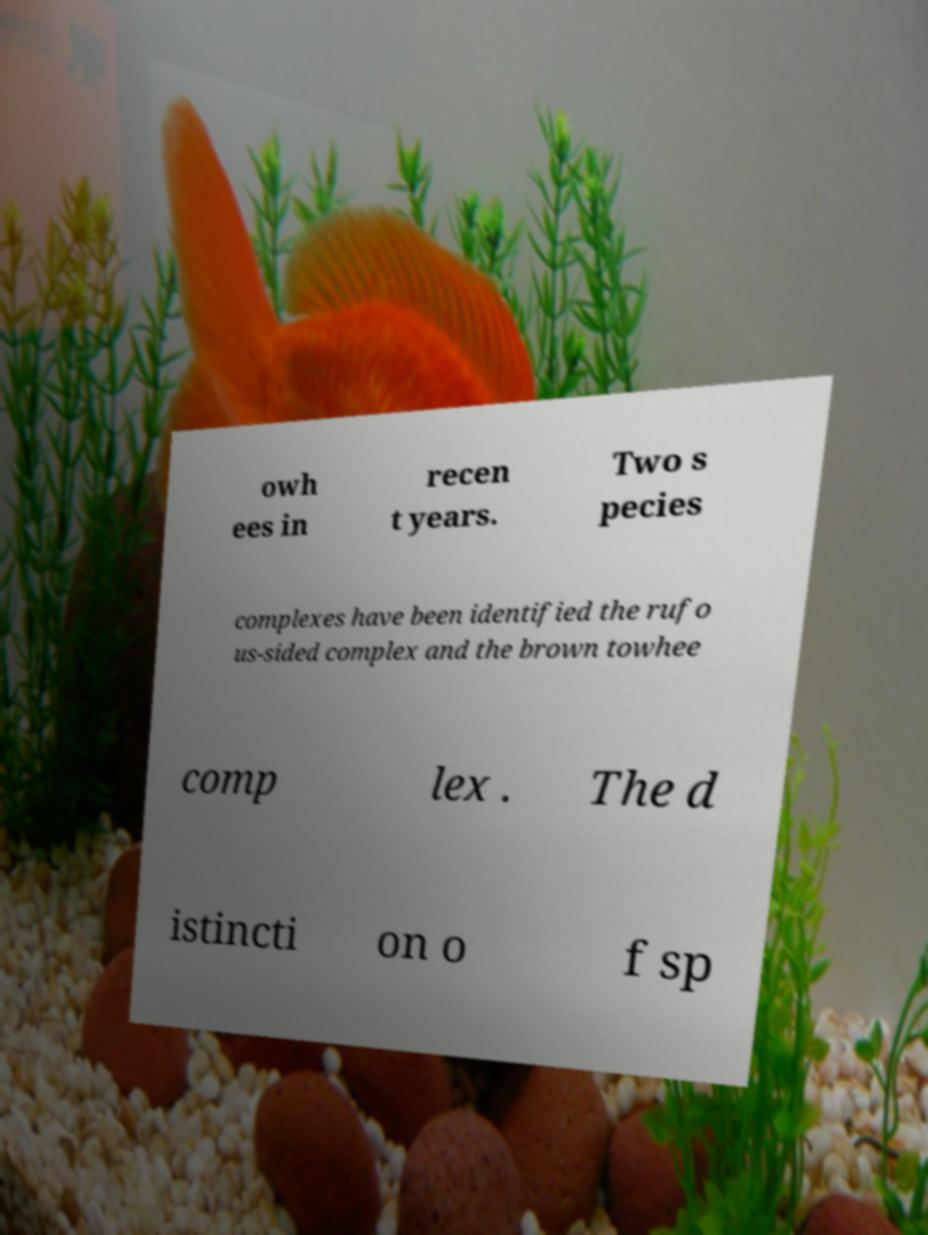For documentation purposes, I need the text within this image transcribed. Could you provide that? owh ees in recen t years. Two s pecies complexes have been identified the rufo us-sided complex and the brown towhee comp lex . The d istincti on o f sp 